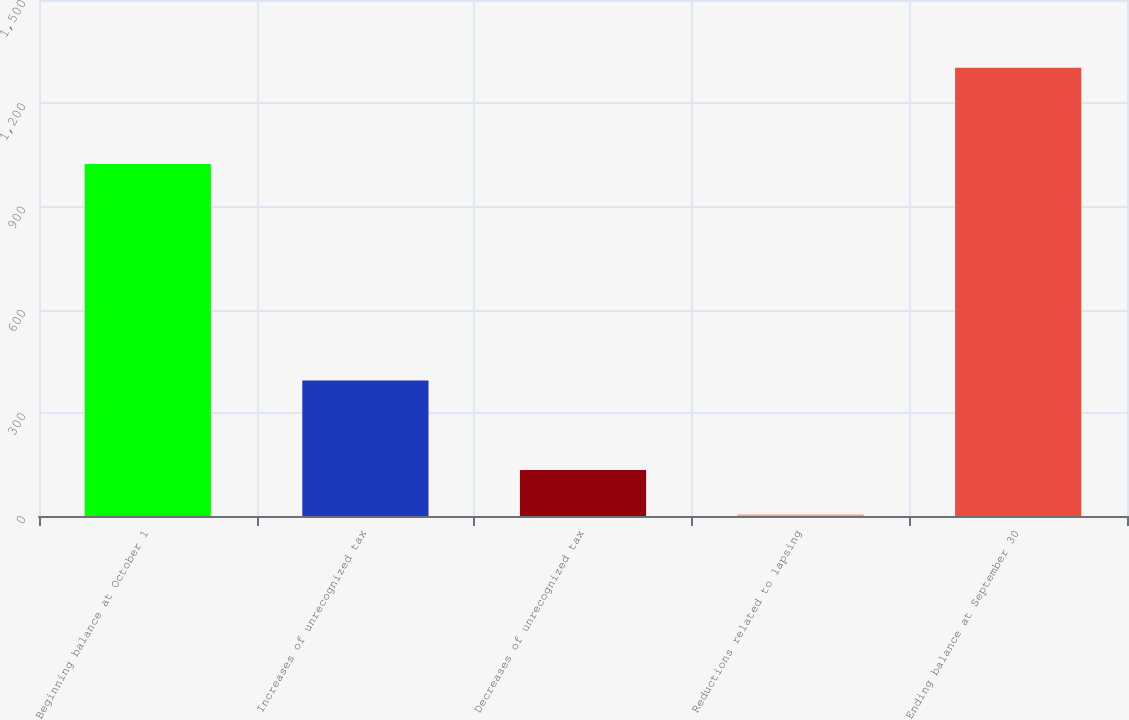Convert chart to OTSL. <chart><loc_0><loc_0><loc_500><loc_500><bar_chart><fcel>Beginning balance at October 1<fcel>Increases of unrecognized tax<fcel>Decreases of unrecognized tax<fcel>Reductions related to lapsing<fcel>Ending balance at September 30<nl><fcel>1023<fcel>393.7<fcel>133.9<fcel>4<fcel>1303<nl></chart> 